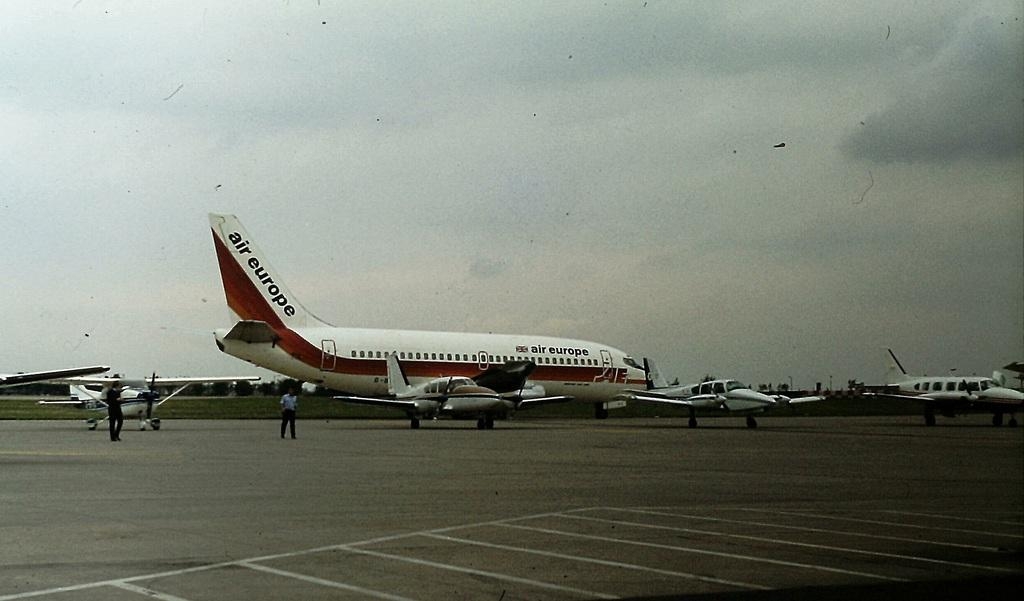<image>
Present a compact description of the photo's key features. The jet plane on the runway says Air Europe. 